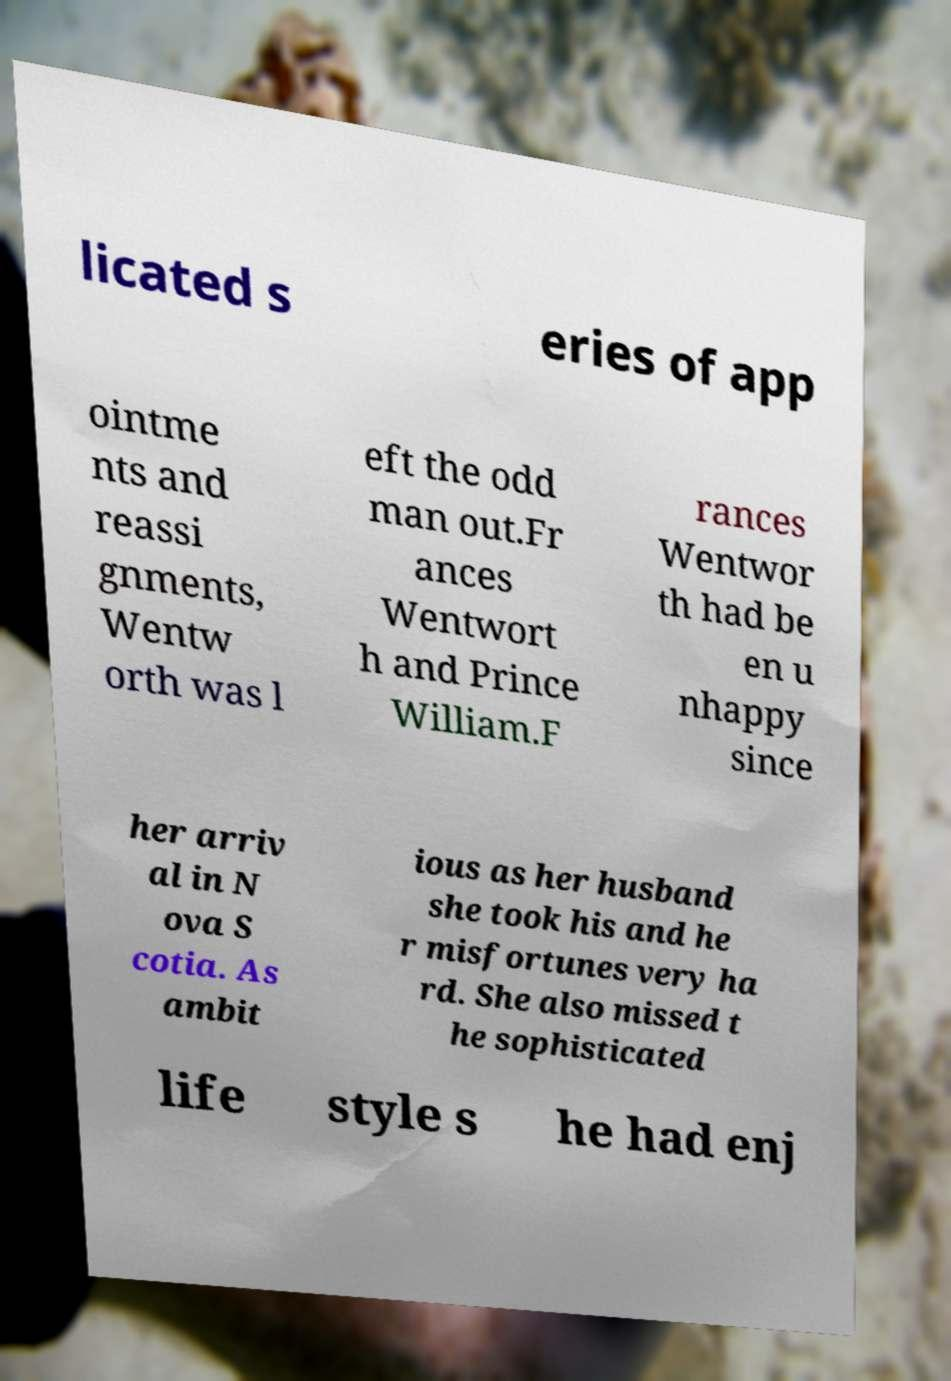I need the written content from this picture converted into text. Can you do that? licated s eries of app ointme nts and reassi gnments, Wentw orth was l eft the odd man out.Fr ances Wentwort h and Prince William.F rances Wentwor th had be en u nhappy since her arriv al in N ova S cotia. As ambit ious as her husband she took his and he r misfortunes very ha rd. She also missed t he sophisticated life style s he had enj 